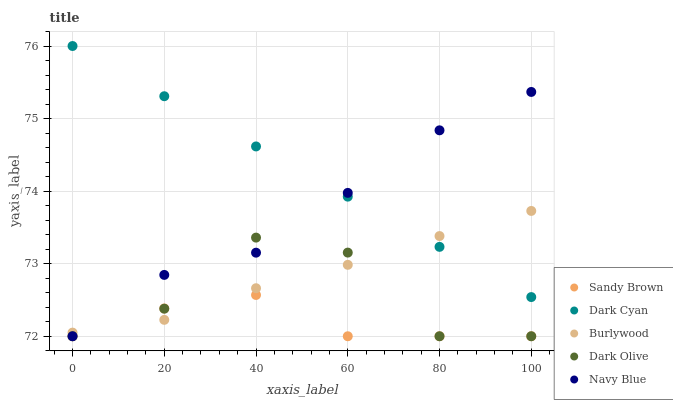Does Sandy Brown have the minimum area under the curve?
Answer yes or no. Yes. Does Dark Cyan have the maximum area under the curve?
Answer yes or no. Yes. Does Burlywood have the minimum area under the curve?
Answer yes or no. No. Does Burlywood have the maximum area under the curve?
Answer yes or no. No. Is Dark Cyan the smoothest?
Answer yes or no. Yes. Is Dark Olive the roughest?
Answer yes or no. Yes. Is Burlywood the smoothest?
Answer yes or no. No. Is Burlywood the roughest?
Answer yes or no. No. Does Dark Olive have the lowest value?
Answer yes or no. Yes. Does Burlywood have the lowest value?
Answer yes or no. No. Does Dark Cyan have the highest value?
Answer yes or no. Yes. Does Burlywood have the highest value?
Answer yes or no. No. Is Sandy Brown less than Dark Cyan?
Answer yes or no. Yes. Is Dark Cyan greater than Dark Olive?
Answer yes or no. Yes. Does Dark Olive intersect Burlywood?
Answer yes or no. Yes. Is Dark Olive less than Burlywood?
Answer yes or no. No. Is Dark Olive greater than Burlywood?
Answer yes or no. No. Does Sandy Brown intersect Dark Cyan?
Answer yes or no. No. 